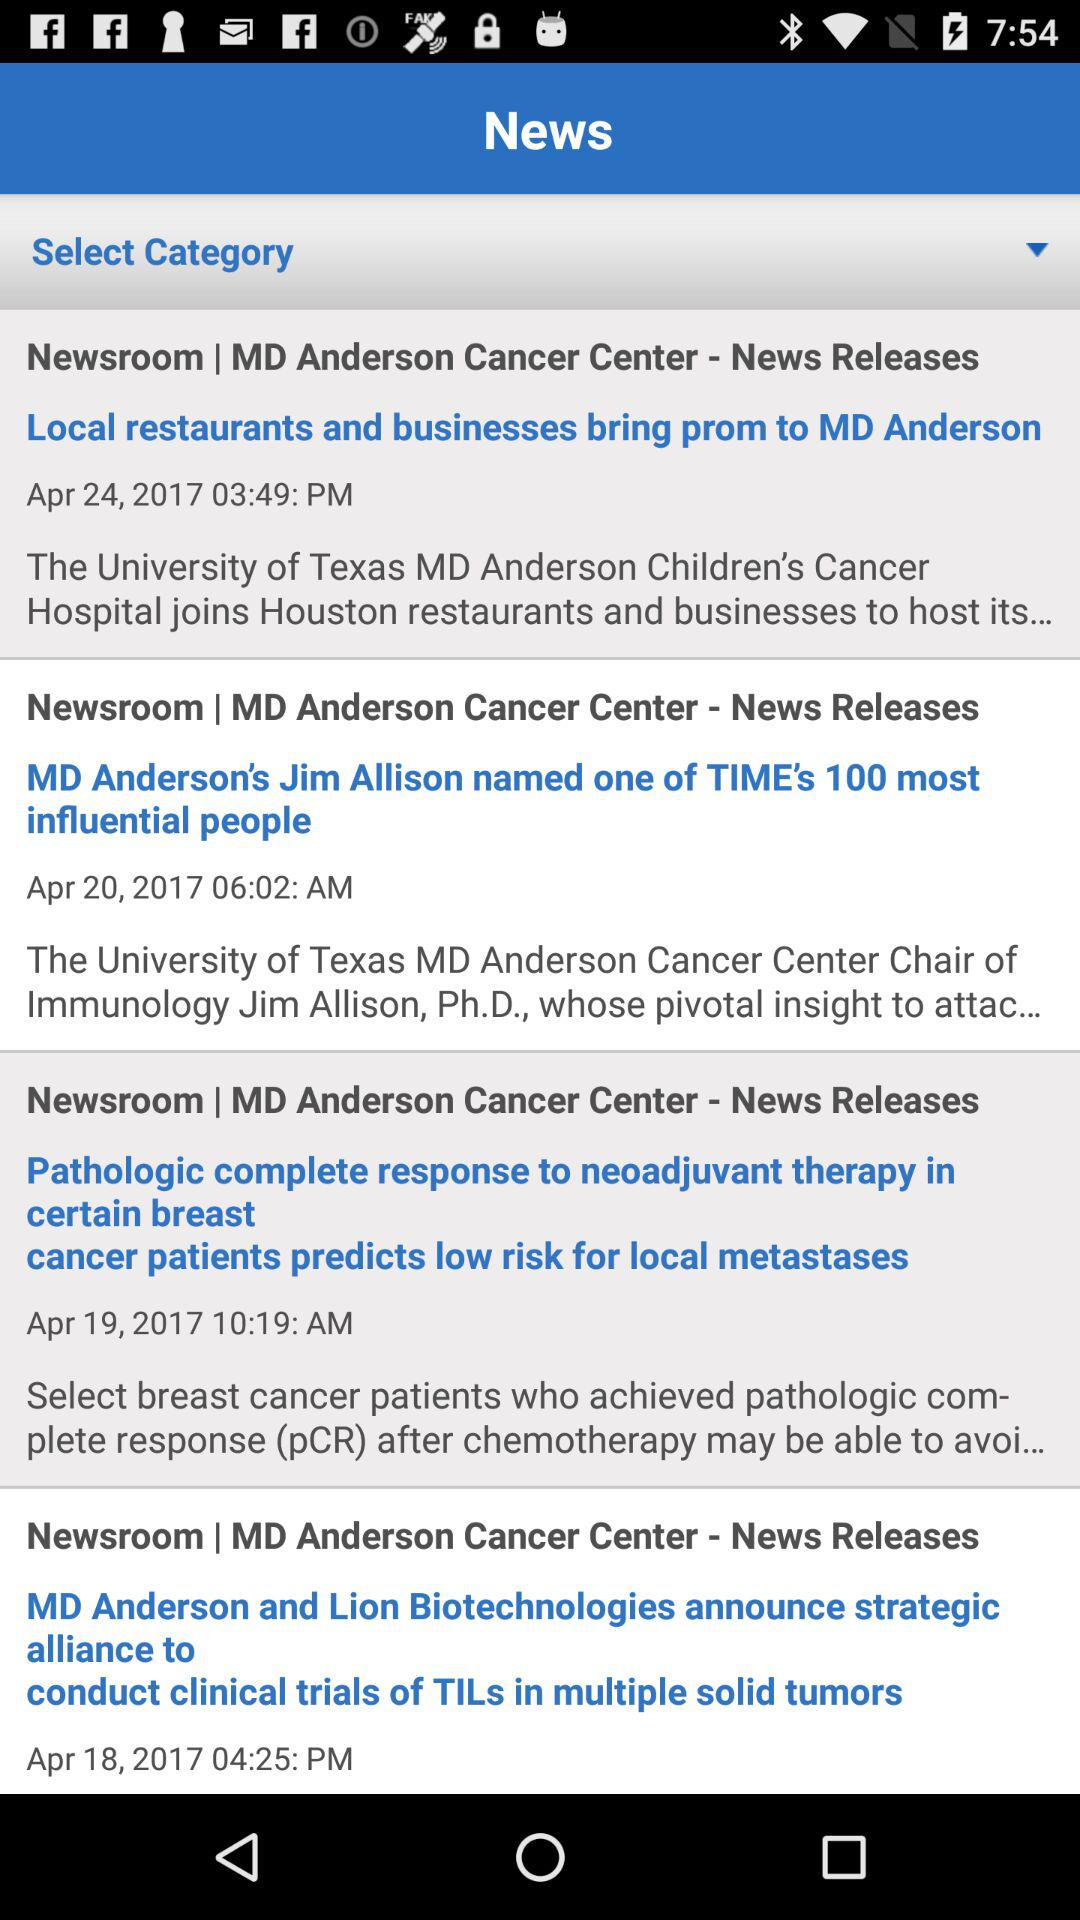What is the date of the news "Local restaurants and businesses bring prom to MD Anderson"? The date is April 24, 2017. 